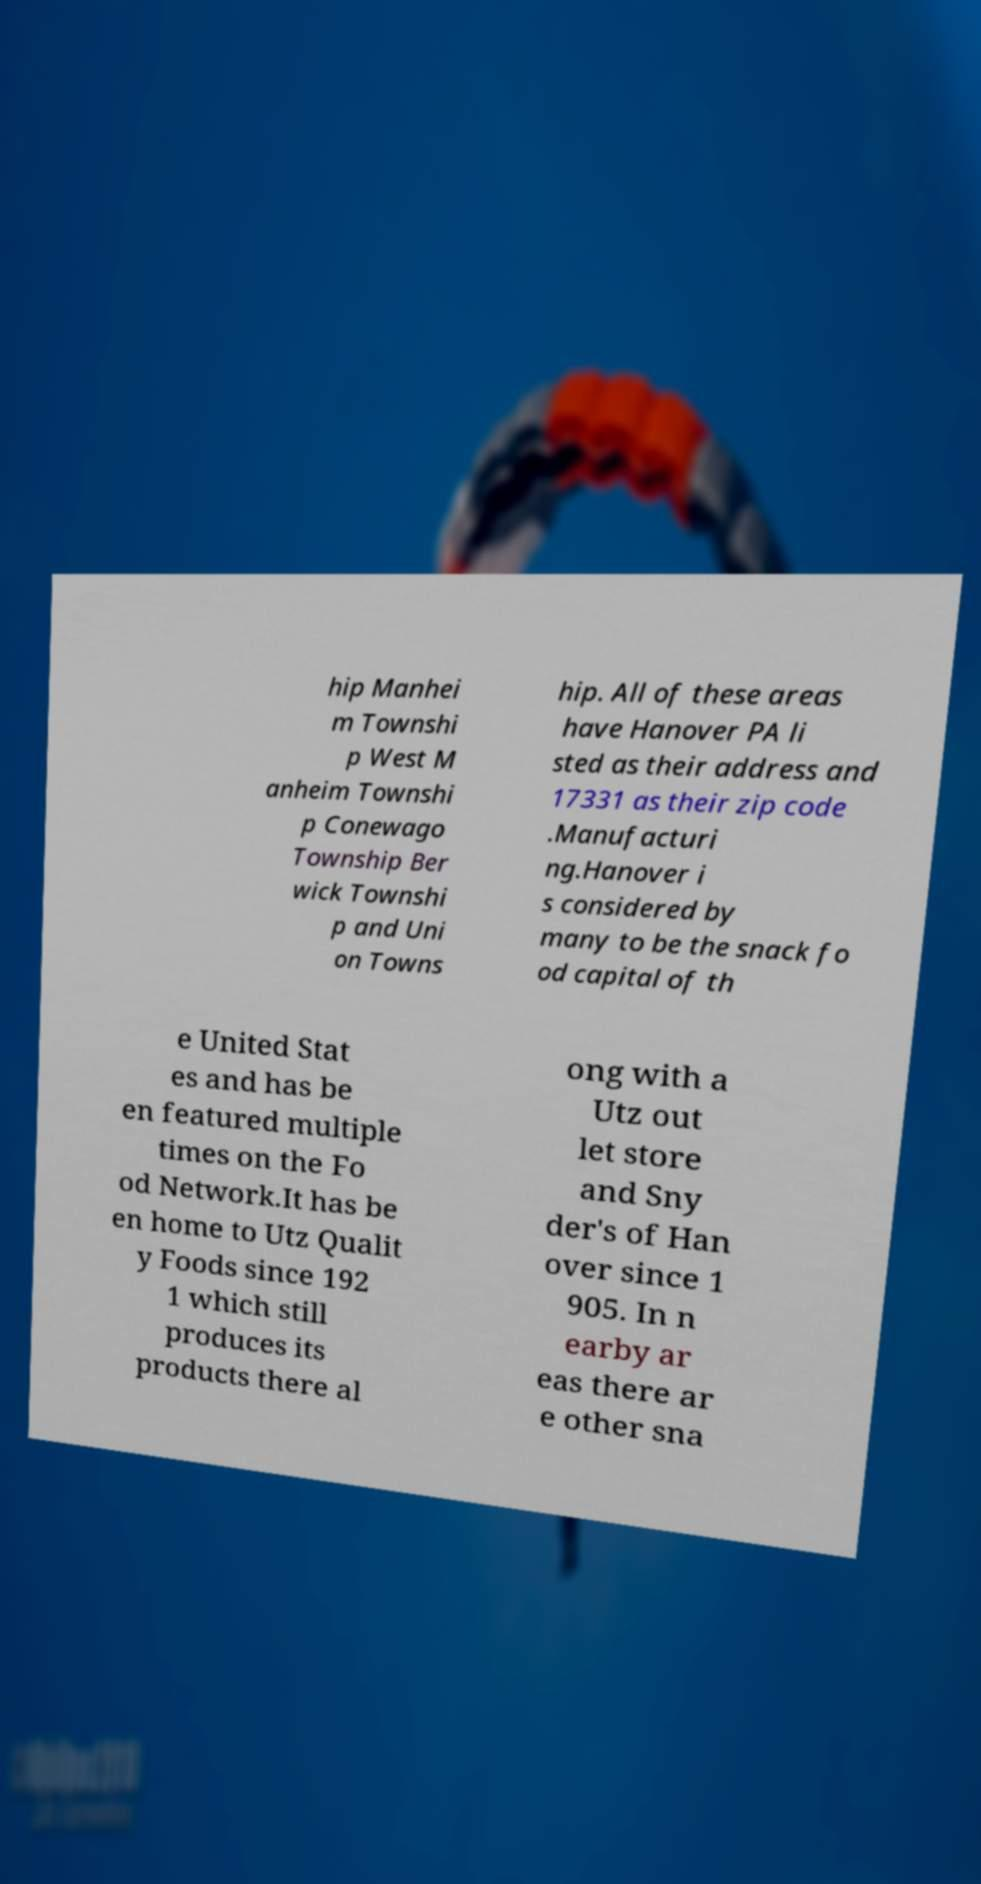There's text embedded in this image that I need extracted. Can you transcribe it verbatim? hip Manhei m Townshi p West M anheim Townshi p Conewago Township Ber wick Townshi p and Uni on Towns hip. All of these areas have Hanover PA li sted as their address and 17331 as their zip code .Manufacturi ng.Hanover i s considered by many to be the snack fo od capital of th e United Stat es and has be en featured multiple times on the Fo od Network.It has be en home to Utz Qualit y Foods since 192 1 which still produces its products there al ong with a Utz out let store and Sny der's of Han over since 1 905. In n earby ar eas there ar e other sna 